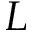Convert formula to latex. <formula><loc_0><loc_0><loc_500><loc_500>L</formula> 